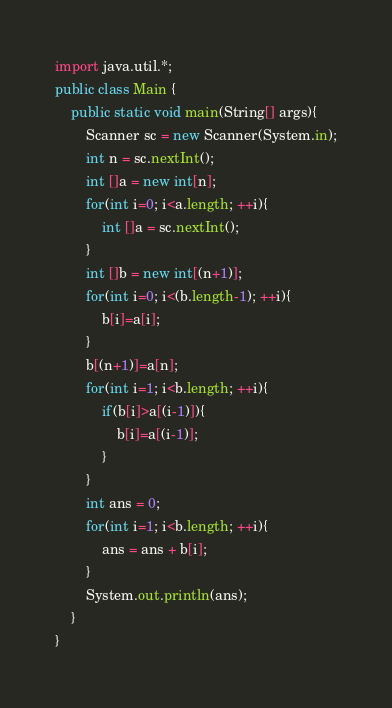<code> <loc_0><loc_0><loc_500><loc_500><_Java_>import java.util.*;
public class Main {
	public static void main(String[] args){
		Scanner sc = new Scanner(System.in);
		int n = sc.nextInt();
		int []a = new int[n];
		for(int i=0; i<a.length; ++i){
		    int []a = sc.nextInt();
		}
		int []b = new int[(n+1)];
		for(int i=0; i<(b.length-1); ++i){
		    b[i]=a[i];
		}
		b[(n+1)]=a[n];
		for(int i=1; i<b.length; ++i){
		    if(b[i]>a[(i-1)]){
		        b[i]=a[(i-1)];
		    }
		}
		int ans = 0;
		for(int i=1; i<b.length; ++i){
		    ans = ans + b[i];
		}
		System.out.println(ans);
	}
}</code> 